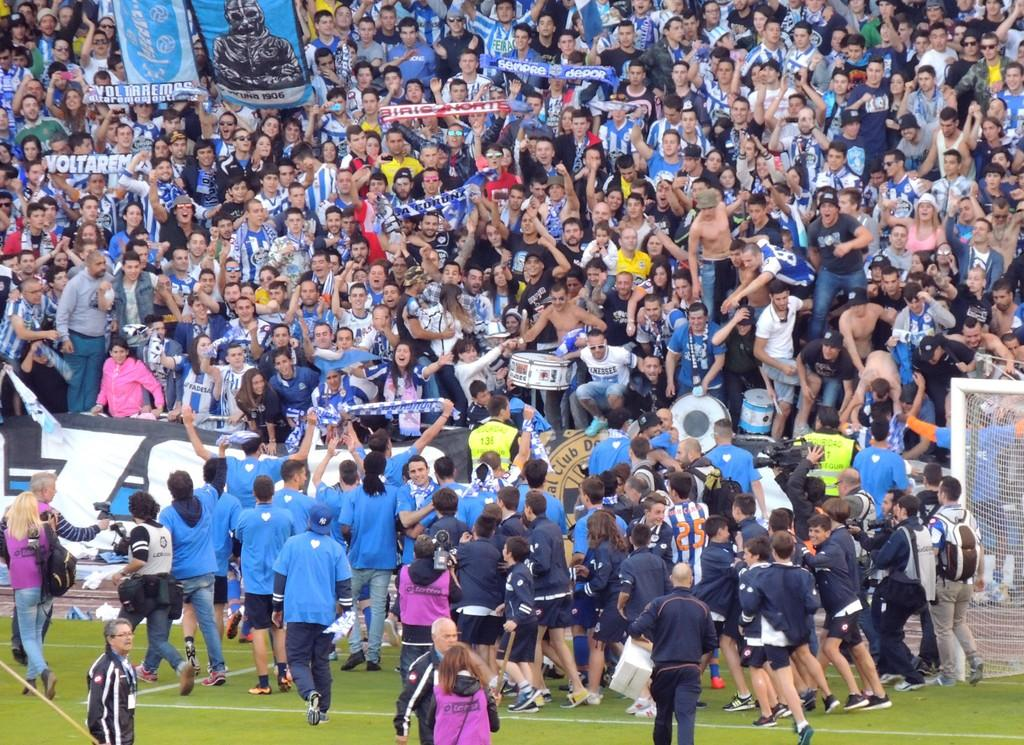<image>
Relay a brief, clear account of the picture shown. Stadium with many fans holding a sign Voltarem 